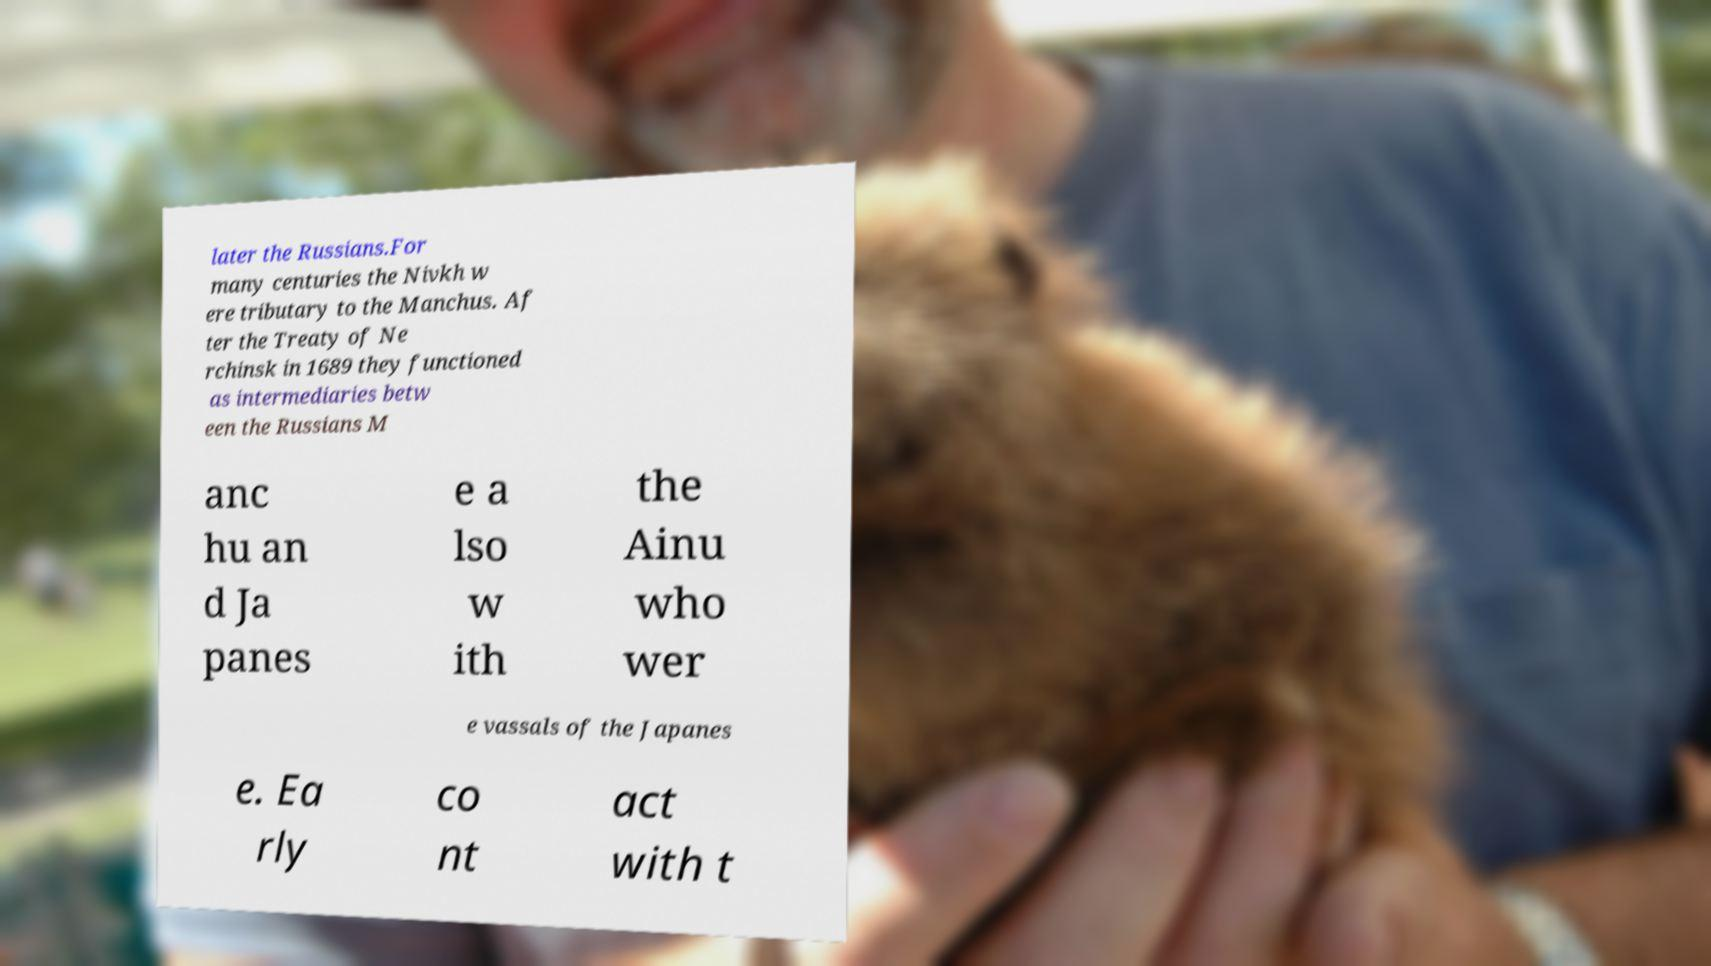Could you extract and type out the text from this image? later the Russians.For many centuries the Nivkh w ere tributary to the Manchus. Af ter the Treaty of Ne rchinsk in 1689 they functioned as intermediaries betw een the Russians M anc hu an d Ja panes e a lso w ith the Ainu who wer e vassals of the Japanes e. Ea rly co nt act with t 